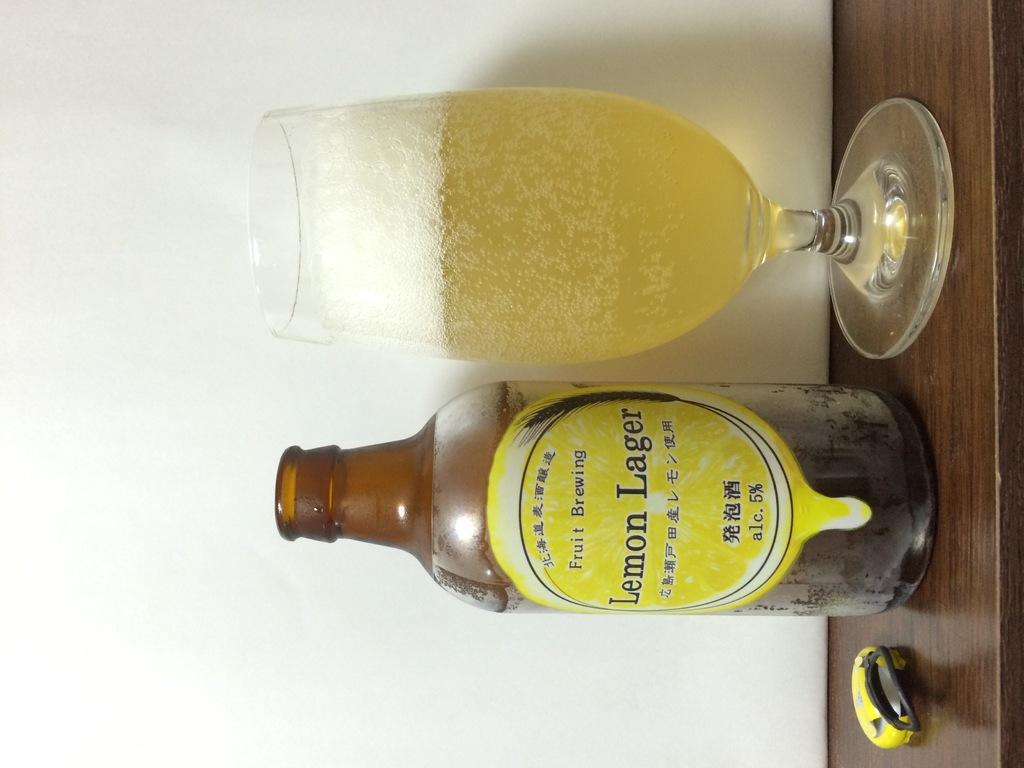What is present on the wooden surface in the image? There is a glass and a bottle on the wooden surface in the image. What type of material is the surface made of? The surface is made of wood. How many clovers can be seen growing on the wooden surface in the image? There are no clovers present on the wooden surface in the image. What type of emotion is expressed by the bottle in the image? The bottle is an inanimate object and cannot express emotions like regret. 